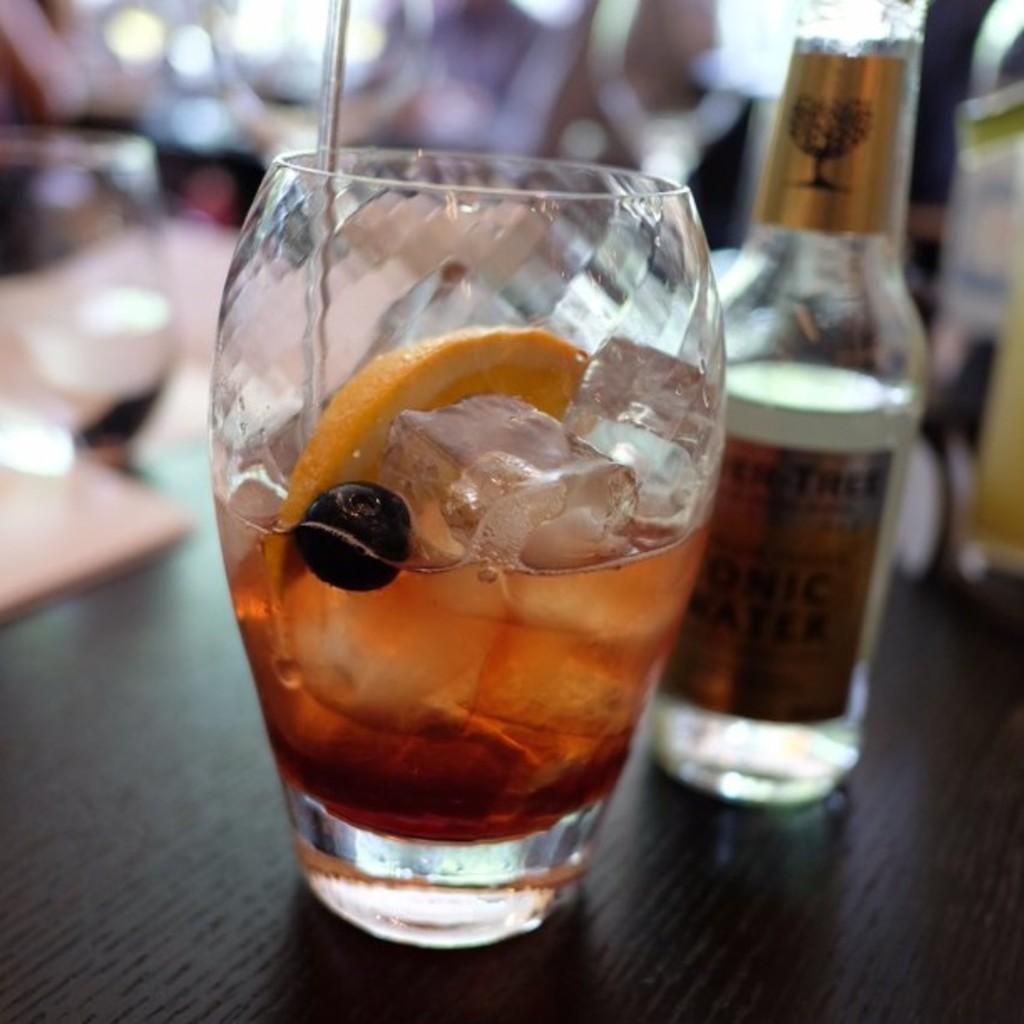What is on the table in the image? There is a glass and a bottle on the table in the image. Can you describe the glass in more detail? The provided facts do not give any additional details about the glass. What is the bottle on the table used for? The provided facts do not specify the contents or purpose of the bottle. What type of flesh can be seen in the image? There is no flesh present in the image; it only features a glass and a bottle on a table. 